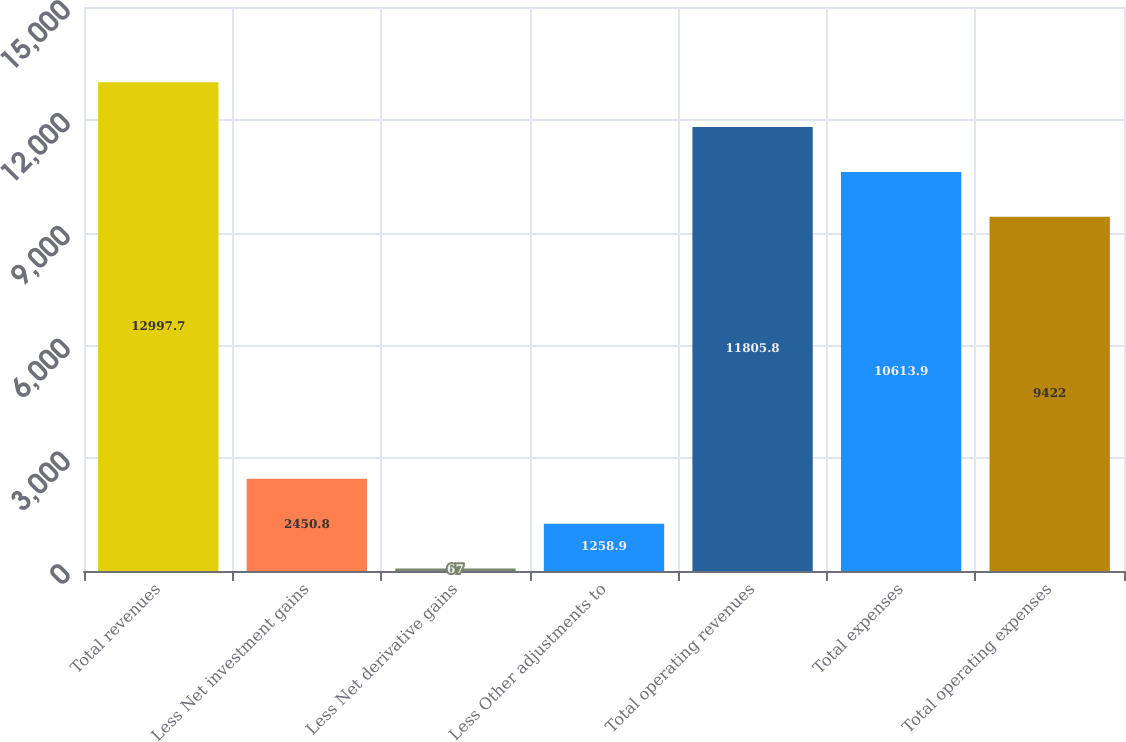<chart> <loc_0><loc_0><loc_500><loc_500><bar_chart><fcel>Total revenues<fcel>Less Net investment gains<fcel>Less Net derivative gains<fcel>Less Other adjustments to<fcel>Total operating revenues<fcel>Total expenses<fcel>Total operating expenses<nl><fcel>12997.7<fcel>2450.8<fcel>67<fcel>1258.9<fcel>11805.8<fcel>10613.9<fcel>9422<nl></chart> 